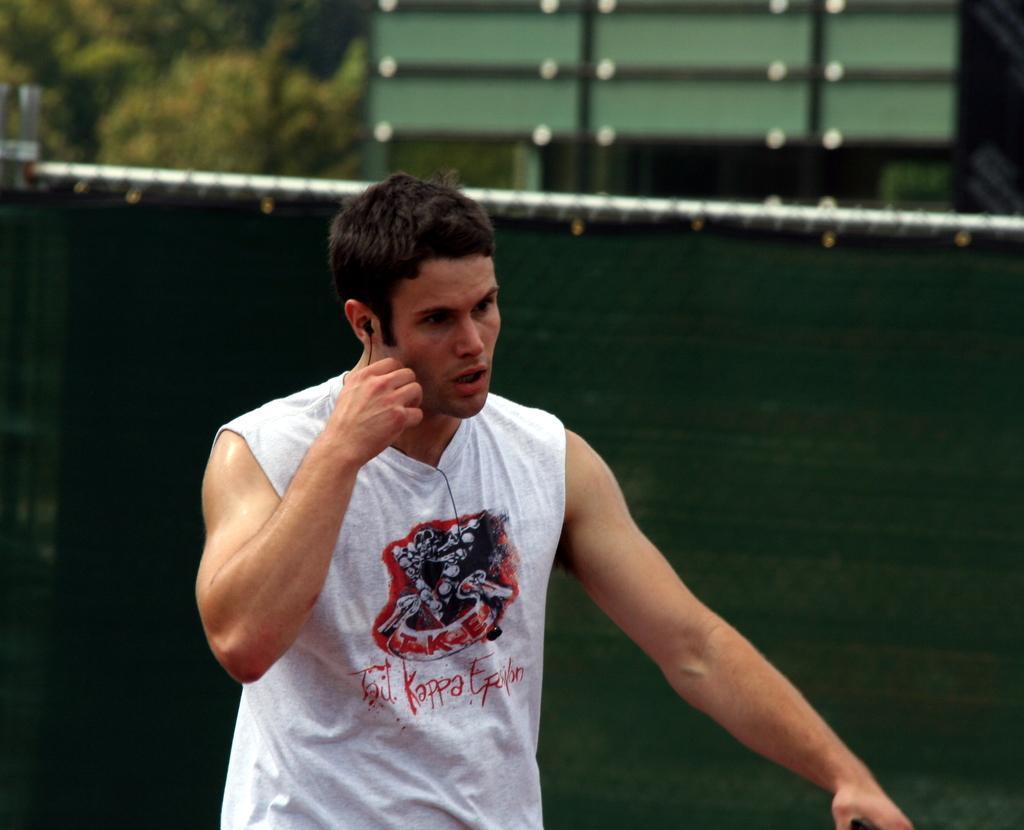Can you describe this image briefly? In this image I can see a person wearing white colored dress. I can see the blurry background which is green in color. 